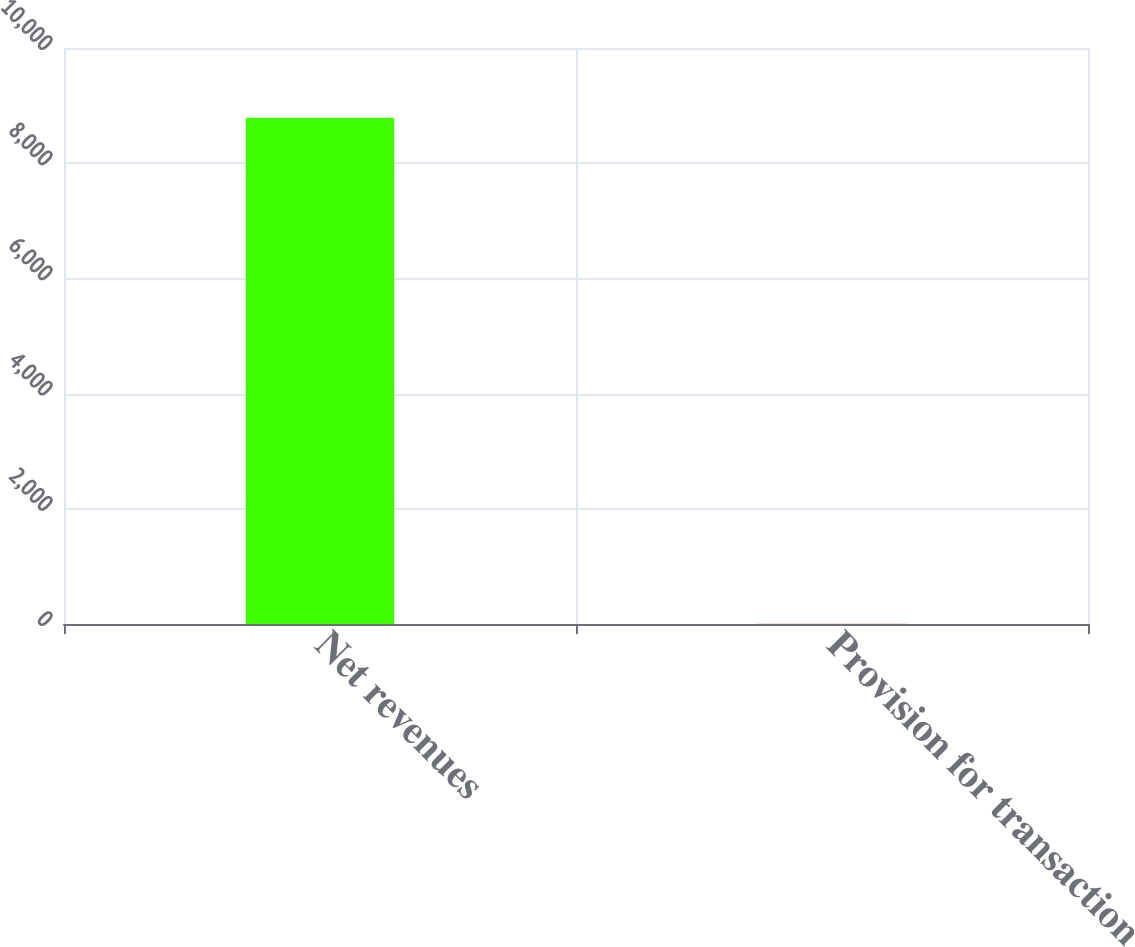<chart> <loc_0><loc_0><loc_500><loc_500><bar_chart><fcel>Net revenues<fcel>Provision for transaction<nl><fcel>8790<fcel>3<nl></chart> 